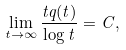<formula> <loc_0><loc_0><loc_500><loc_500>\lim _ { t \rightarrow \infty } \frac { t q ( t ) } { \log t } = C ,</formula> 